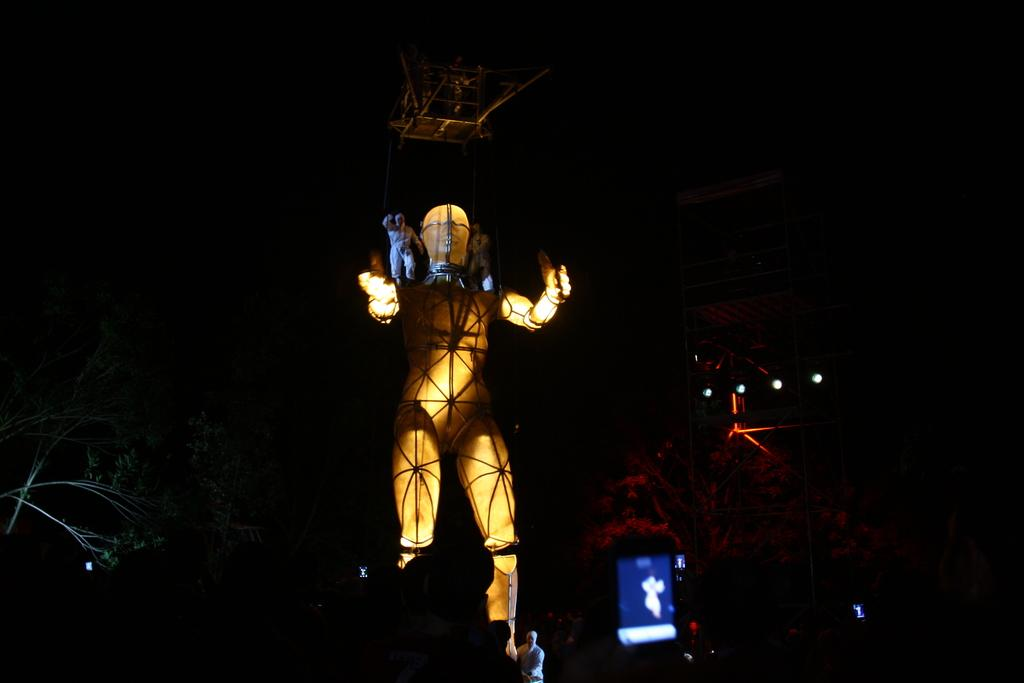What type of objects can be seen in the image? There are statues, lights, and trees in the image. Can you describe the person in the image? There is a person in the image, but their specific appearance or actions are not mentioned in the facts. What is the person holding in the image? The facts mention that there is a camera in the image, but it does not specify who is holding it. What is the lighting situation in the image? There are lights in the image, but their intensity or color is not mentioned in the facts. What is the background of the image like? The background of the image is dark. How many ducks are sitting on the hook in the image? There are no ducks or hooks present in the image. What type of winter clothing is the person wearing in the image? There is no mention of winter clothing or the season in the image. 